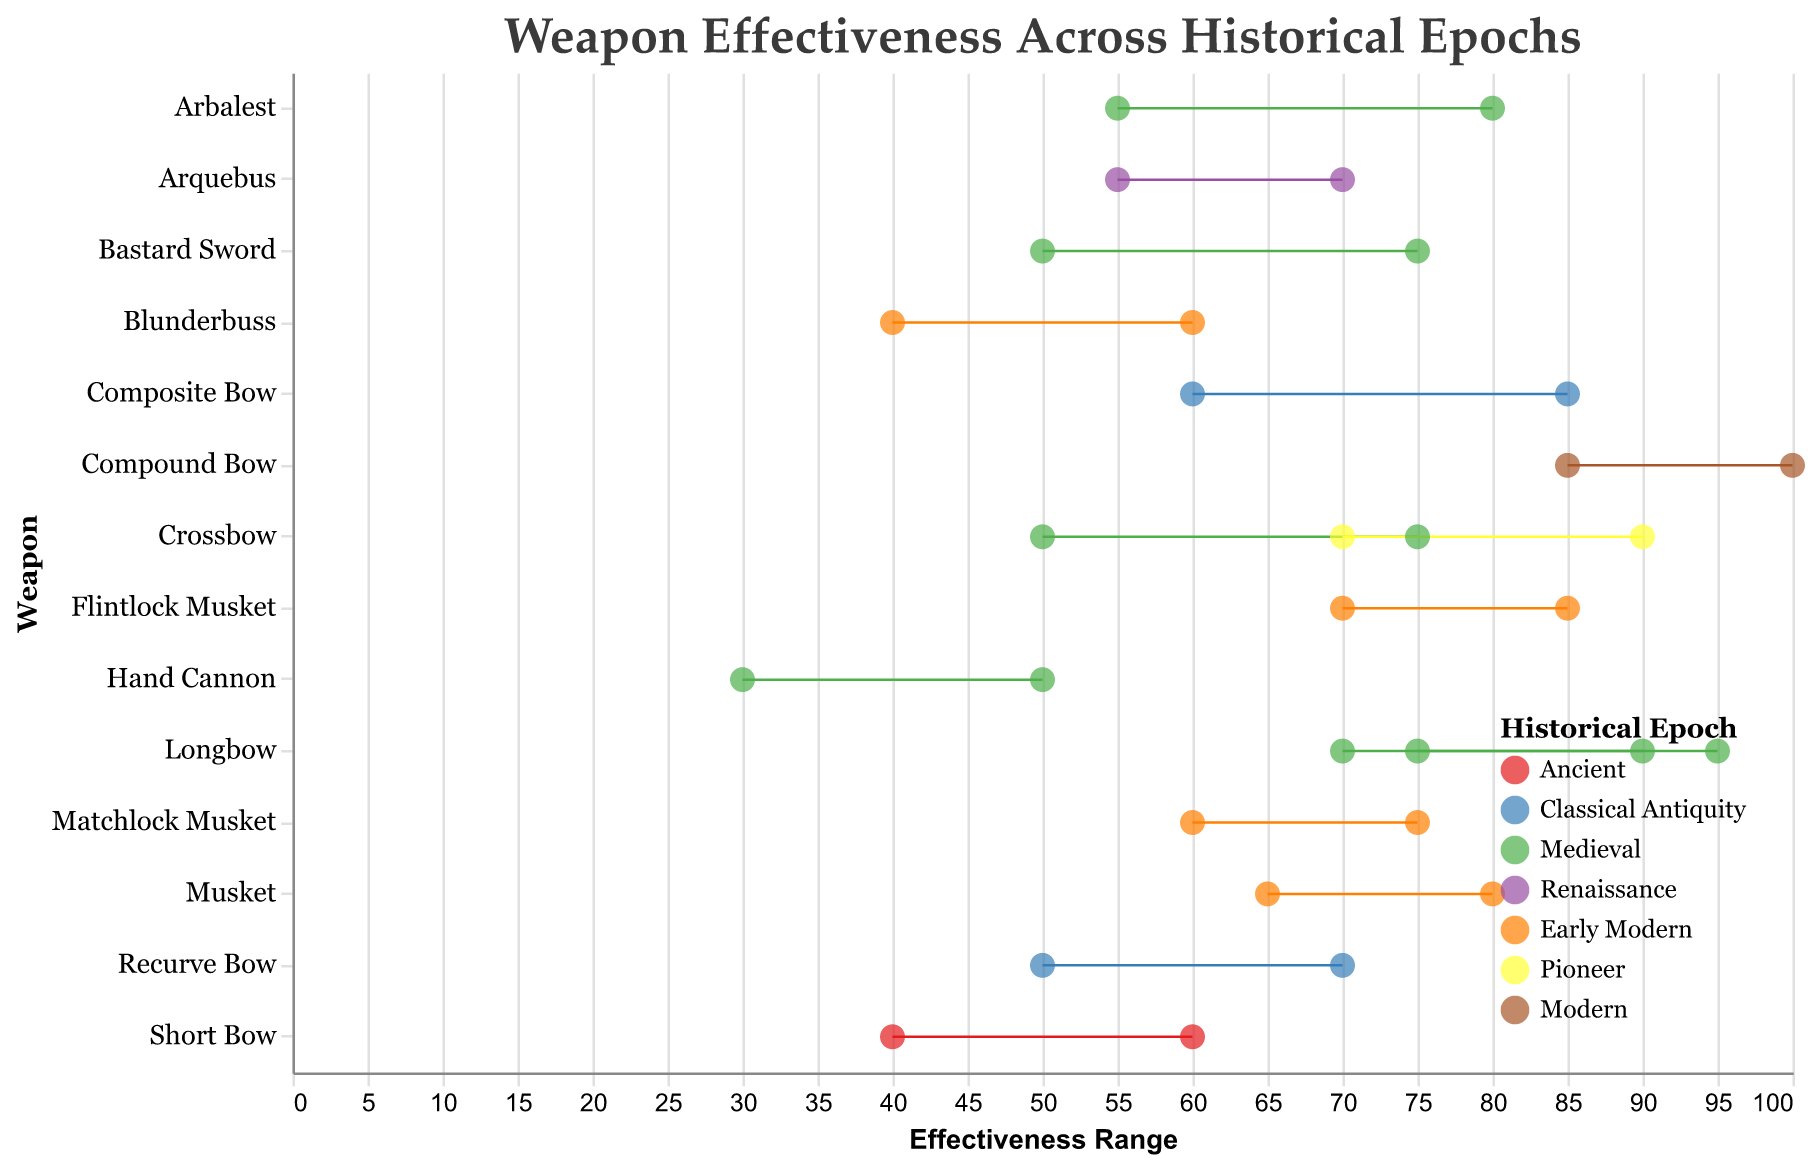What is the title of the plot? The title can be seen at the top of the figure and reads "Weapon Effectiveness Across Historical Epochs."
Answer: Weapon Effectiveness Across Historical Epochs Which weapon from the Medieval epoch has the highest maximum effectiveness? By looking at the upper end of the range bars for the Medieval weapons, the Longbow has the highest maximum effectiveness at 95.
Answer: Longbow Which weapon has the largest range of effectiveness in the Early Modern epoch? By examining the length of the range bars, the Flintlock Musket has a range from 70 to 85, which is 15, making it the largest range in the Early Modern epoch.
Answer: Flintlock Musket Compare the minimum effectiveness of Hand Cannon in the Medieval epoch with the minimum effectiveness of Musket in the Early Modern epoch. Which is lower? The minimum effectiveness of Hand Cannon is 30, while the Musket has a minimum effectiveness of 65. So, the Hand Cannon is lower.
Answer: Hand Cannon What is the average maximum effectiveness of the weapons from the Classical Antiquity epoch? The weapons from Classical Antiquity are Composite Bow (85) and Recurve Bow (70). The average of these maximum values is (85 + 70) / 2 = 77.5.
Answer: 77.5 Which epoch includes a weapon with a minimum effectiveness of 85? The only weapon listed with a minimum effectiveness of 85 is the Compound Bow, and it belongs to the Modern epoch.
Answer: Modern How does the maximum effectiveness of the Crossbow in the Pioneer epoch compare to that of the Longbow in the Medieval epoch? The maximum effectiveness of the Crossbow in the Pioneer epoch is 90, while the Longbow in the Medieval epoch has a maximum effectiveness of 95. Therefore, the Longbow has higher maximum effectiveness.
Answer: Longbow What is the range of effectiveness for the Blunderbuss in the Early Modern epoch? The Blunderbuss in the Early Modern epoch has a minimum effectiveness of 40 and a maximum of 60. The range is calculated as 60 - 40 = 20.
Answer: 20 